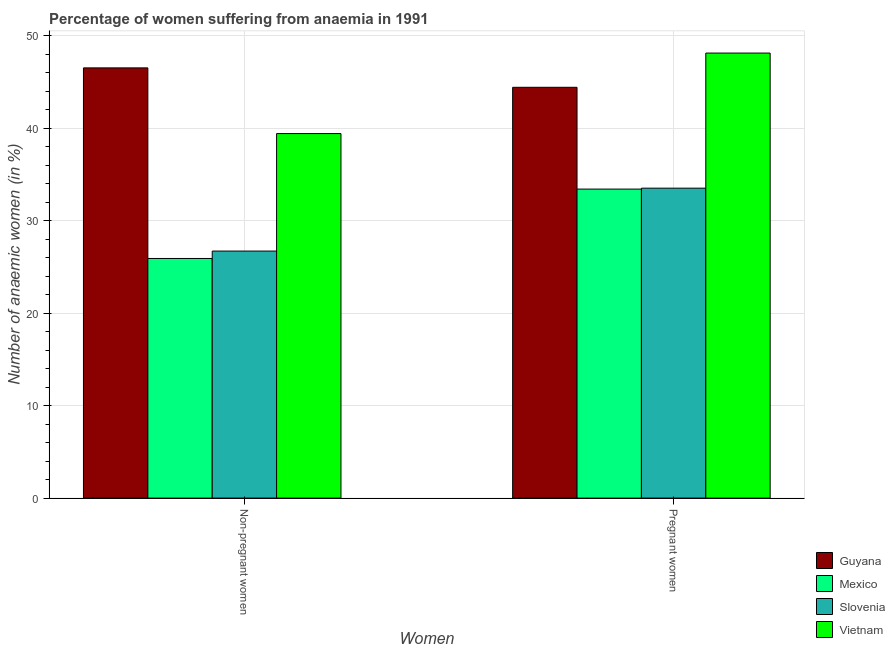How many different coloured bars are there?
Offer a very short reply. 4. How many groups of bars are there?
Your answer should be compact. 2. Are the number of bars per tick equal to the number of legend labels?
Ensure brevity in your answer.  Yes. Are the number of bars on each tick of the X-axis equal?
Make the answer very short. Yes. How many bars are there on the 1st tick from the left?
Keep it short and to the point. 4. What is the label of the 2nd group of bars from the left?
Provide a succinct answer. Pregnant women. What is the percentage of non-pregnant anaemic women in Mexico?
Keep it short and to the point. 25.9. Across all countries, what is the maximum percentage of non-pregnant anaemic women?
Make the answer very short. 46.5. Across all countries, what is the minimum percentage of non-pregnant anaemic women?
Your response must be concise. 25.9. In which country was the percentage of pregnant anaemic women maximum?
Make the answer very short. Vietnam. In which country was the percentage of non-pregnant anaemic women minimum?
Your response must be concise. Mexico. What is the total percentage of pregnant anaemic women in the graph?
Your response must be concise. 159.4. What is the difference between the percentage of pregnant anaemic women in Guyana and that in Slovenia?
Offer a very short reply. 10.9. What is the difference between the percentage of non-pregnant anaemic women in Mexico and the percentage of pregnant anaemic women in Vietnam?
Give a very brief answer. -22.2. What is the average percentage of non-pregnant anaemic women per country?
Offer a very short reply. 34.62. What is the difference between the percentage of non-pregnant anaemic women and percentage of pregnant anaemic women in Slovenia?
Provide a succinct answer. -6.8. In how many countries, is the percentage of pregnant anaemic women greater than 32 %?
Provide a succinct answer. 4. What is the ratio of the percentage of non-pregnant anaemic women in Mexico to that in Vietnam?
Your answer should be compact. 0.66. In how many countries, is the percentage of pregnant anaemic women greater than the average percentage of pregnant anaemic women taken over all countries?
Offer a terse response. 2. What does the 1st bar from the left in Pregnant women represents?
Ensure brevity in your answer.  Guyana. What does the 4th bar from the right in Non-pregnant women represents?
Your answer should be very brief. Guyana. How many bars are there?
Your response must be concise. 8. How many countries are there in the graph?
Offer a terse response. 4. What is the difference between two consecutive major ticks on the Y-axis?
Offer a terse response. 10. Are the values on the major ticks of Y-axis written in scientific E-notation?
Offer a terse response. No. How many legend labels are there?
Keep it short and to the point. 4. How are the legend labels stacked?
Ensure brevity in your answer.  Vertical. What is the title of the graph?
Give a very brief answer. Percentage of women suffering from anaemia in 1991. What is the label or title of the X-axis?
Provide a short and direct response. Women. What is the label or title of the Y-axis?
Offer a terse response. Number of anaemic women (in %). What is the Number of anaemic women (in %) of Guyana in Non-pregnant women?
Your answer should be very brief. 46.5. What is the Number of anaemic women (in %) of Mexico in Non-pregnant women?
Make the answer very short. 25.9. What is the Number of anaemic women (in %) in Slovenia in Non-pregnant women?
Offer a very short reply. 26.7. What is the Number of anaemic women (in %) in Vietnam in Non-pregnant women?
Provide a short and direct response. 39.4. What is the Number of anaemic women (in %) of Guyana in Pregnant women?
Provide a short and direct response. 44.4. What is the Number of anaemic women (in %) in Mexico in Pregnant women?
Make the answer very short. 33.4. What is the Number of anaemic women (in %) of Slovenia in Pregnant women?
Ensure brevity in your answer.  33.5. What is the Number of anaemic women (in %) of Vietnam in Pregnant women?
Keep it short and to the point. 48.1. Across all Women, what is the maximum Number of anaemic women (in %) of Guyana?
Your answer should be very brief. 46.5. Across all Women, what is the maximum Number of anaemic women (in %) in Mexico?
Offer a very short reply. 33.4. Across all Women, what is the maximum Number of anaemic women (in %) in Slovenia?
Keep it short and to the point. 33.5. Across all Women, what is the maximum Number of anaemic women (in %) of Vietnam?
Provide a short and direct response. 48.1. Across all Women, what is the minimum Number of anaemic women (in %) in Guyana?
Provide a short and direct response. 44.4. Across all Women, what is the minimum Number of anaemic women (in %) in Mexico?
Ensure brevity in your answer.  25.9. Across all Women, what is the minimum Number of anaemic women (in %) of Slovenia?
Offer a very short reply. 26.7. Across all Women, what is the minimum Number of anaemic women (in %) in Vietnam?
Offer a very short reply. 39.4. What is the total Number of anaemic women (in %) in Guyana in the graph?
Offer a very short reply. 90.9. What is the total Number of anaemic women (in %) of Mexico in the graph?
Ensure brevity in your answer.  59.3. What is the total Number of anaemic women (in %) of Slovenia in the graph?
Your response must be concise. 60.2. What is the total Number of anaemic women (in %) in Vietnam in the graph?
Your response must be concise. 87.5. What is the difference between the Number of anaemic women (in %) in Guyana in Non-pregnant women and that in Pregnant women?
Your answer should be compact. 2.1. What is the difference between the Number of anaemic women (in %) in Mexico in Non-pregnant women and that in Pregnant women?
Provide a succinct answer. -7.5. What is the difference between the Number of anaemic women (in %) of Slovenia in Non-pregnant women and that in Pregnant women?
Make the answer very short. -6.8. What is the difference between the Number of anaemic women (in %) in Vietnam in Non-pregnant women and that in Pregnant women?
Give a very brief answer. -8.7. What is the difference between the Number of anaemic women (in %) in Guyana in Non-pregnant women and the Number of anaemic women (in %) in Mexico in Pregnant women?
Provide a short and direct response. 13.1. What is the difference between the Number of anaemic women (in %) in Guyana in Non-pregnant women and the Number of anaemic women (in %) in Slovenia in Pregnant women?
Your answer should be very brief. 13. What is the difference between the Number of anaemic women (in %) in Guyana in Non-pregnant women and the Number of anaemic women (in %) in Vietnam in Pregnant women?
Your response must be concise. -1.6. What is the difference between the Number of anaemic women (in %) in Mexico in Non-pregnant women and the Number of anaemic women (in %) in Vietnam in Pregnant women?
Keep it short and to the point. -22.2. What is the difference between the Number of anaemic women (in %) of Slovenia in Non-pregnant women and the Number of anaemic women (in %) of Vietnam in Pregnant women?
Give a very brief answer. -21.4. What is the average Number of anaemic women (in %) in Guyana per Women?
Keep it short and to the point. 45.45. What is the average Number of anaemic women (in %) of Mexico per Women?
Your response must be concise. 29.65. What is the average Number of anaemic women (in %) in Slovenia per Women?
Ensure brevity in your answer.  30.1. What is the average Number of anaemic women (in %) in Vietnam per Women?
Provide a succinct answer. 43.75. What is the difference between the Number of anaemic women (in %) of Guyana and Number of anaemic women (in %) of Mexico in Non-pregnant women?
Offer a very short reply. 20.6. What is the difference between the Number of anaemic women (in %) in Guyana and Number of anaemic women (in %) in Slovenia in Non-pregnant women?
Provide a short and direct response. 19.8. What is the difference between the Number of anaemic women (in %) of Mexico and Number of anaemic women (in %) of Slovenia in Non-pregnant women?
Offer a very short reply. -0.8. What is the difference between the Number of anaemic women (in %) of Guyana and Number of anaemic women (in %) of Slovenia in Pregnant women?
Your answer should be compact. 10.9. What is the difference between the Number of anaemic women (in %) of Guyana and Number of anaemic women (in %) of Vietnam in Pregnant women?
Give a very brief answer. -3.7. What is the difference between the Number of anaemic women (in %) in Mexico and Number of anaemic women (in %) in Vietnam in Pregnant women?
Offer a very short reply. -14.7. What is the difference between the Number of anaemic women (in %) in Slovenia and Number of anaemic women (in %) in Vietnam in Pregnant women?
Provide a succinct answer. -14.6. What is the ratio of the Number of anaemic women (in %) in Guyana in Non-pregnant women to that in Pregnant women?
Provide a succinct answer. 1.05. What is the ratio of the Number of anaemic women (in %) of Mexico in Non-pregnant women to that in Pregnant women?
Offer a terse response. 0.78. What is the ratio of the Number of anaemic women (in %) in Slovenia in Non-pregnant women to that in Pregnant women?
Your response must be concise. 0.8. What is the ratio of the Number of anaemic women (in %) of Vietnam in Non-pregnant women to that in Pregnant women?
Your response must be concise. 0.82. What is the difference between the highest and the second highest Number of anaemic women (in %) of Mexico?
Provide a succinct answer. 7.5. What is the difference between the highest and the second highest Number of anaemic women (in %) of Slovenia?
Offer a terse response. 6.8. What is the difference between the highest and the second highest Number of anaemic women (in %) in Vietnam?
Your response must be concise. 8.7. What is the difference between the highest and the lowest Number of anaemic women (in %) in Slovenia?
Offer a very short reply. 6.8. What is the difference between the highest and the lowest Number of anaemic women (in %) of Vietnam?
Your answer should be compact. 8.7. 